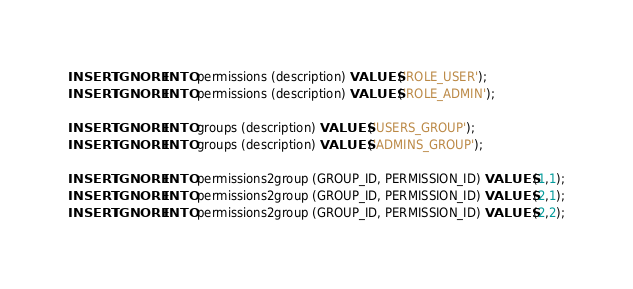<code> <loc_0><loc_0><loc_500><loc_500><_SQL_>INSERT IGNORE INTO permissions (description) VALUES ('ROLE_USER');
INSERT IGNORE INTO permissions (description) VALUES ('ROLE_ADMIN');

INSERT IGNORE INTO groups (description) VALUES ('USERS_GROUP');
INSERT IGNORE INTO groups (description) VALUES ('ADMINS_GROUP');

INSERT IGNORE INTO permissions2group (GROUP_ID, PERMISSION_ID) VALUES (1,1);
INSERT IGNORE INTO permissions2group (GROUP_ID, PERMISSION_ID) VALUES (2,1);
INSERT IGNORE INTO permissions2group (GROUP_ID, PERMISSION_ID) VALUES (2,2);
</code> 